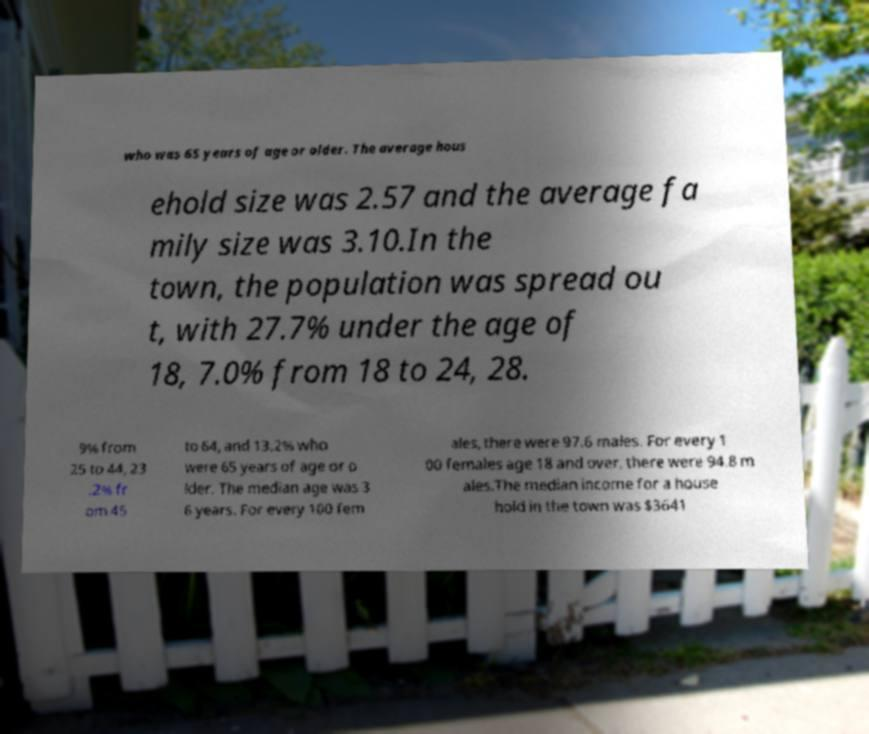Please identify and transcribe the text found in this image. who was 65 years of age or older. The average hous ehold size was 2.57 and the average fa mily size was 3.10.In the town, the population was spread ou t, with 27.7% under the age of 18, 7.0% from 18 to 24, 28. 9% from 25 to 44, 23 .2% fr om 45 to 64, and 13.2% who were 65 years of age or o lder. The median age was 3 6 years. For every 100 fem ales, there were 97.6 males. For every 1 00 females age 18 and over, there were 94.8 m ales.The median income for a house hold in the town was $3641 